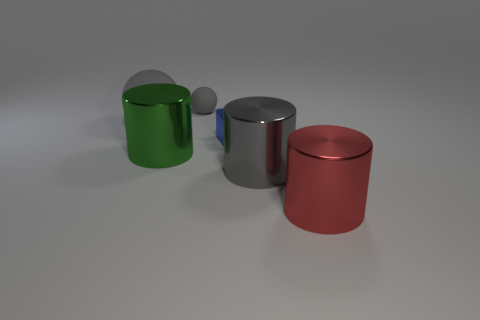Do the matte thing in front of the tiny gray matte thing and the large green thing have the same shape?
Provide a short and direct response. No. How many yellow objects are either large objects or small cubes?
Provide a short and direct response. 0. What material is the small object that is the same shape as the large gray rubber thing?
Give a very brief answer. Rubber. There is a big gray thing that is behind the big green thing; what is its shape?
Make the answer very short. Sphere. Are there any tiny blocks made of the same material as the big gray sphere?
Offer a terse response. No. Is the block the same size as the green metal cylinder?
Offer a terse response. No. How many balls are either small matte things or large matte objects?
Offer a very short reply. 2. There is another sphere that is the same color as the tiny rubber sphere; what is it made of?
Provide a short and direct response. Rubber. How many other large green shiny things have the same shape as the big green object?
Keep it short and to the point. 0. Is the number of cubes to the right of the cube greater than the number of large red shiny cylinders left of the big gray metal cylinder?
Make the answer very short. No. 